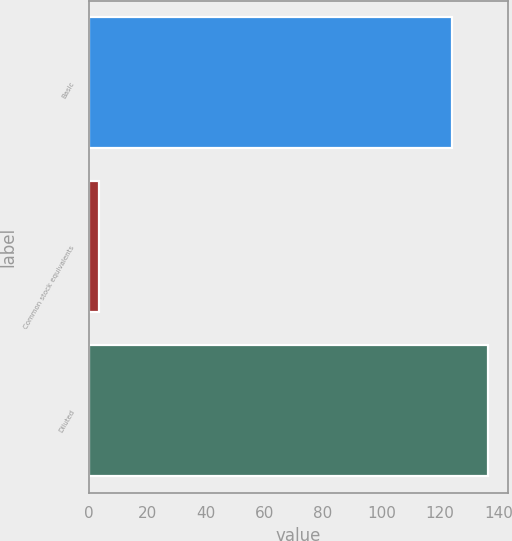<chart> <loc_0><loc_0><loc_500><loc_500><bar_chart><fcel>Basic<fcel>Common stock equivalents<fcel>Diluted<nl><fcel>124.1<fcel>3.4<fcel>136.51<nl></chart> 